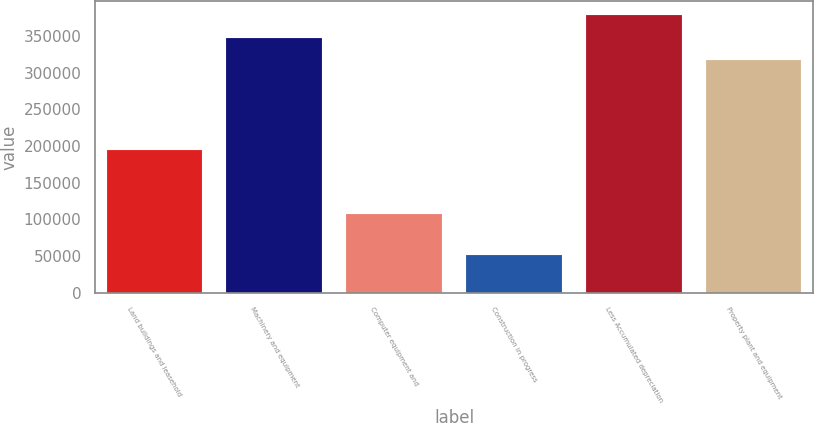Convert chart to OTSL. <chart><loc_0><loc_0><loc_500><loc_500><bar_chart><fcel>Land buildings and leasehold<fcel>Machinery and equipment<fcel>Computer equipment and<fcel>Construction in progress<fcel>Less Accumulated depreciation<fcel>Property plant and equipment<nl><fcel>194923<fcel>348058<fcel>107743<fcel>51834<fcel>378681<fcel>317435<nl></chart> 